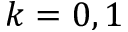<formula> <loc_0><loc_0><loc_500><loc_500>k = 0 , 1</formula> 